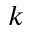<formula> <loc_0><loc_0><loc_500><loc_500>k</formula> 